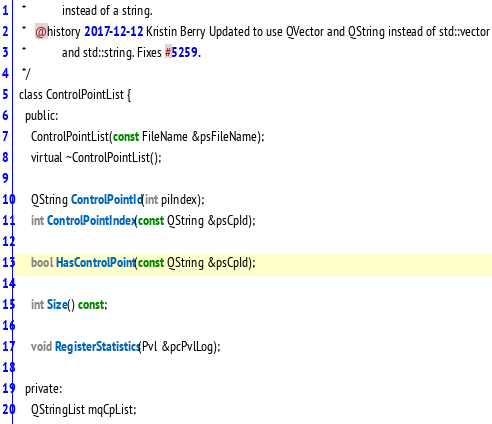<code> <loc_0><loc_0><loc_500><loc_500><_C_>   *            instead of a string.
   *   @history 2017-12-12 Kristin Berry Updated to use QVector and QString instead of std::vector
   *            and std::string. Fixes #5259.
   */
  class ControlPointList {
    public:
      ControlPointList(const FileName &psFileName);
      virtual ~ControlPointList();

      QString ControlPointId(int piIndex);
      int ControlPointIndex(const QString &psCpId);

      bool HasControlPoint(const QString &psCpId);

      int Size() const;

      void RegisterStatistics(Pvl &pcPvlLog);

    private:
      QStringList mqCpList;
</code> 